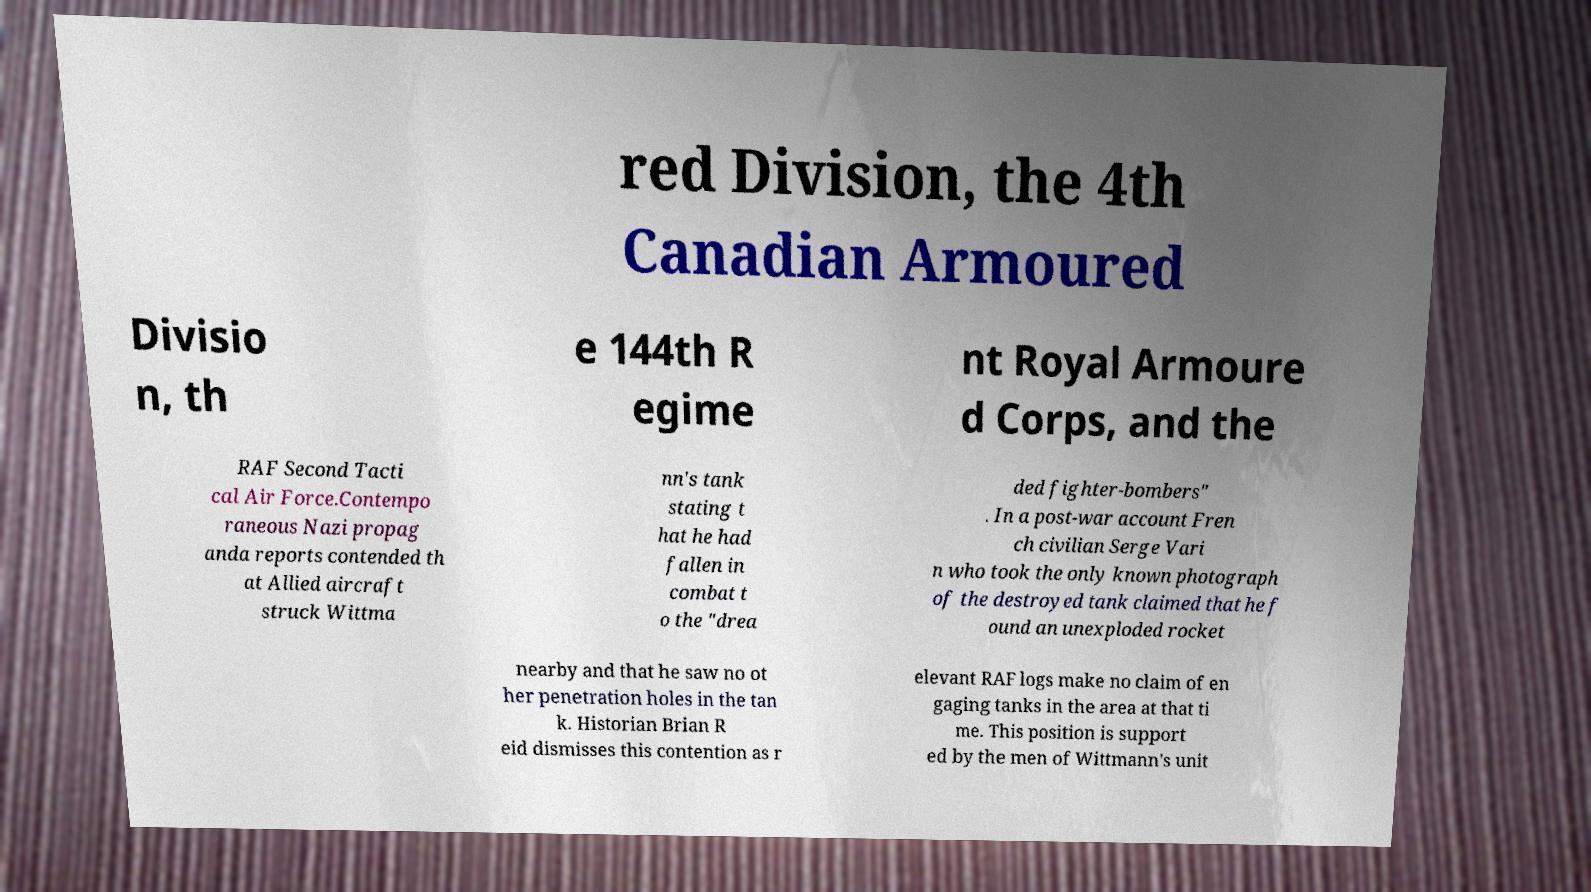For documentation purposes, I need the text within this image transcribed. Could you provide that? red Division, the 4th Canadian Armoured Divisio n, th e 144th R egime nt Royal Armoure d Corps, and the RAF Second Tacti cal Air Force.Contempo raneous Nazi propag anda reports contended th at Allied aircraft struck Wittma nn's tank stating t hat he had fallen in combat t o the "drea ded fighter-bombers" . In a post-war account Fren ch civilian Serge Vari n who took the only known photograph of the destroyed tank claimed that he f ound an unexploded rocket nearby and that he saw no ot her penetration holes in the tan k. Historian Brian R eid dismisses this contention as r elevant RAF logs make no claim of en gaging tanks in the area at that ti me. This position is support ed by the men of Wittmann's unit 